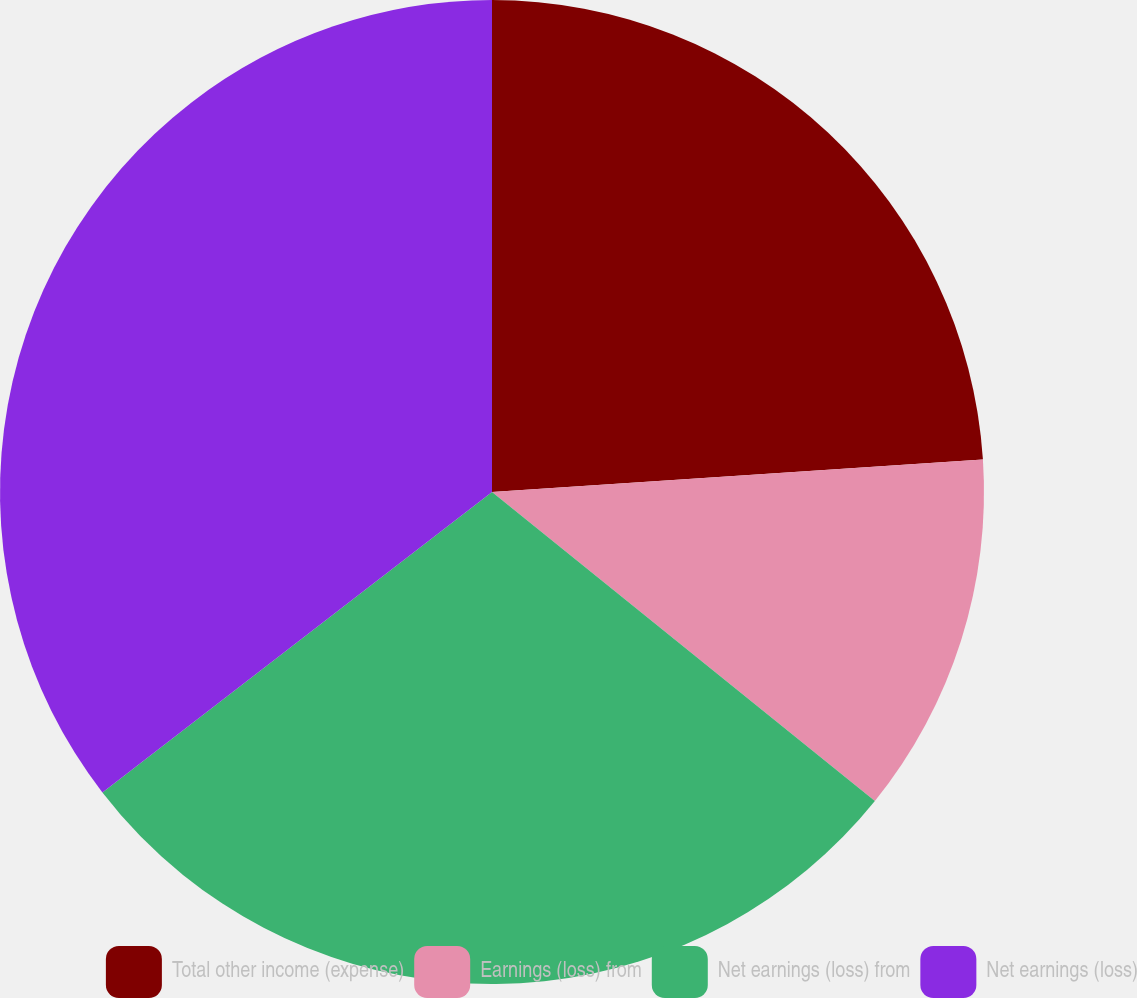Convert chart to OTSL. <chart><loc_0><loc_0><loc_500><loc_500><pie_chart><fcel>Total other income (expense)<fcel>Earnings (loss) from<fcel>Net earnings (loss) from<fcel>Net earnings (loss)<nl><fcel>23.95%<fcel>11.86%<fcel>28.74%<fcel>35.46%<nl></chart> 